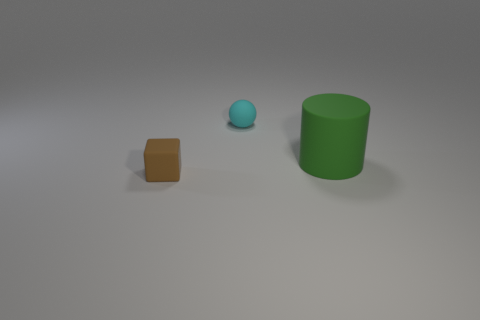Add 2 yellow shiny objects. How many objects exist? 5 Subtract all balls. How many objects are left? 2 Subtract all purple cubes. Subtract all red spheres. How many cubes are left? 1 Subtract all green cylinders. How many green balls are left? 0 Subtract all small yellow rubber cylinders. Subtract all matte things. How many objects are left? 0 Add 3 large matte objects. How many large matte objects are left? 4 Add 3 cyan matte spheres. How many cyan matte spheres exist? 4 Subtract 0 green cubes. How many objects are left? 3 